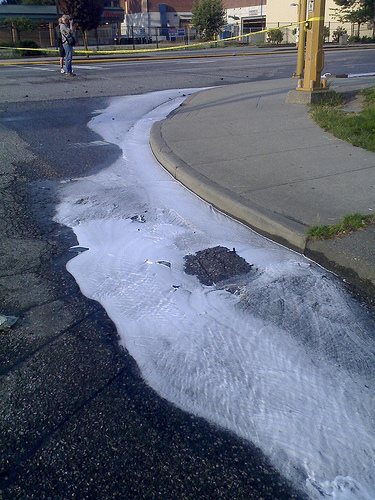<image>
Is the yellow tape on the poll? Yes. Looking at the image, I can see the yellow tape is positioned on top of the poll, with the poll providing support. 